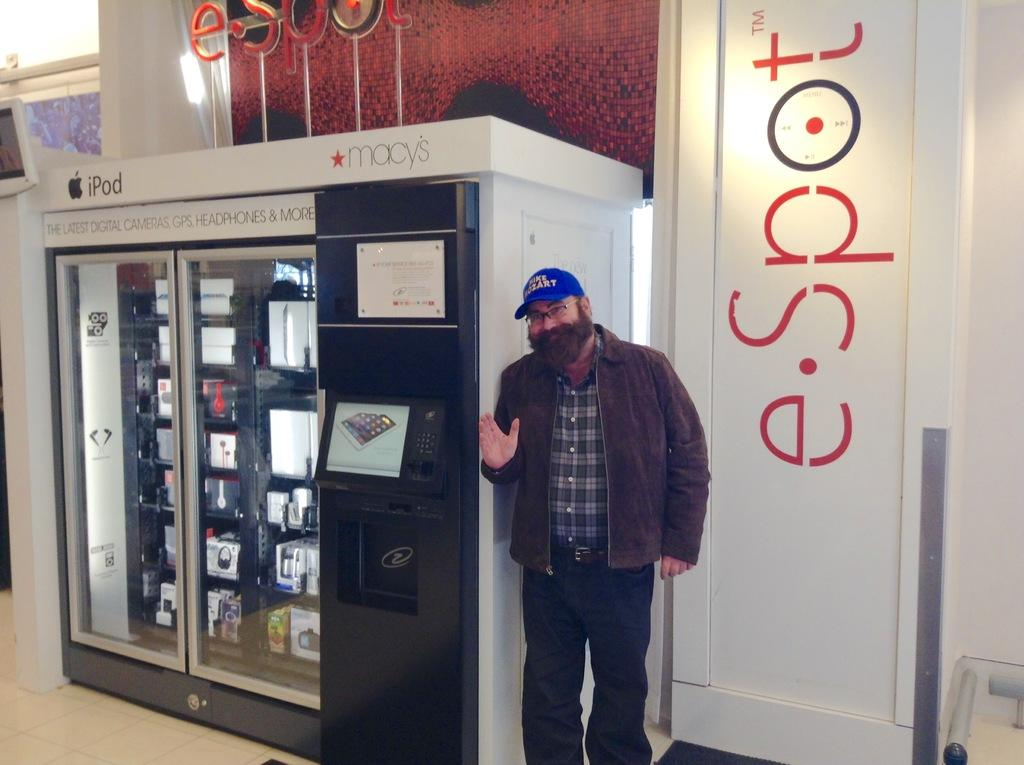What is the main subject in the foreground of the image? There is a person standing in the foreground of the image. What is the person standing on? The person is standing on the floor. What is located beside the person? The person is beside a cupboard. What can be seen in the background of the image? There is a wall in the background of the image, and there is a curtain associated with the wall. What architectural feature is present in the background? There is a door in the background of the image. What type of room might this image have been taken in? The image may have been taken in a hall, given the presence of a cupboard and a door. Can you see the person's sister standing on a hill in the background of the image? There is no sister or hill present in the image. 